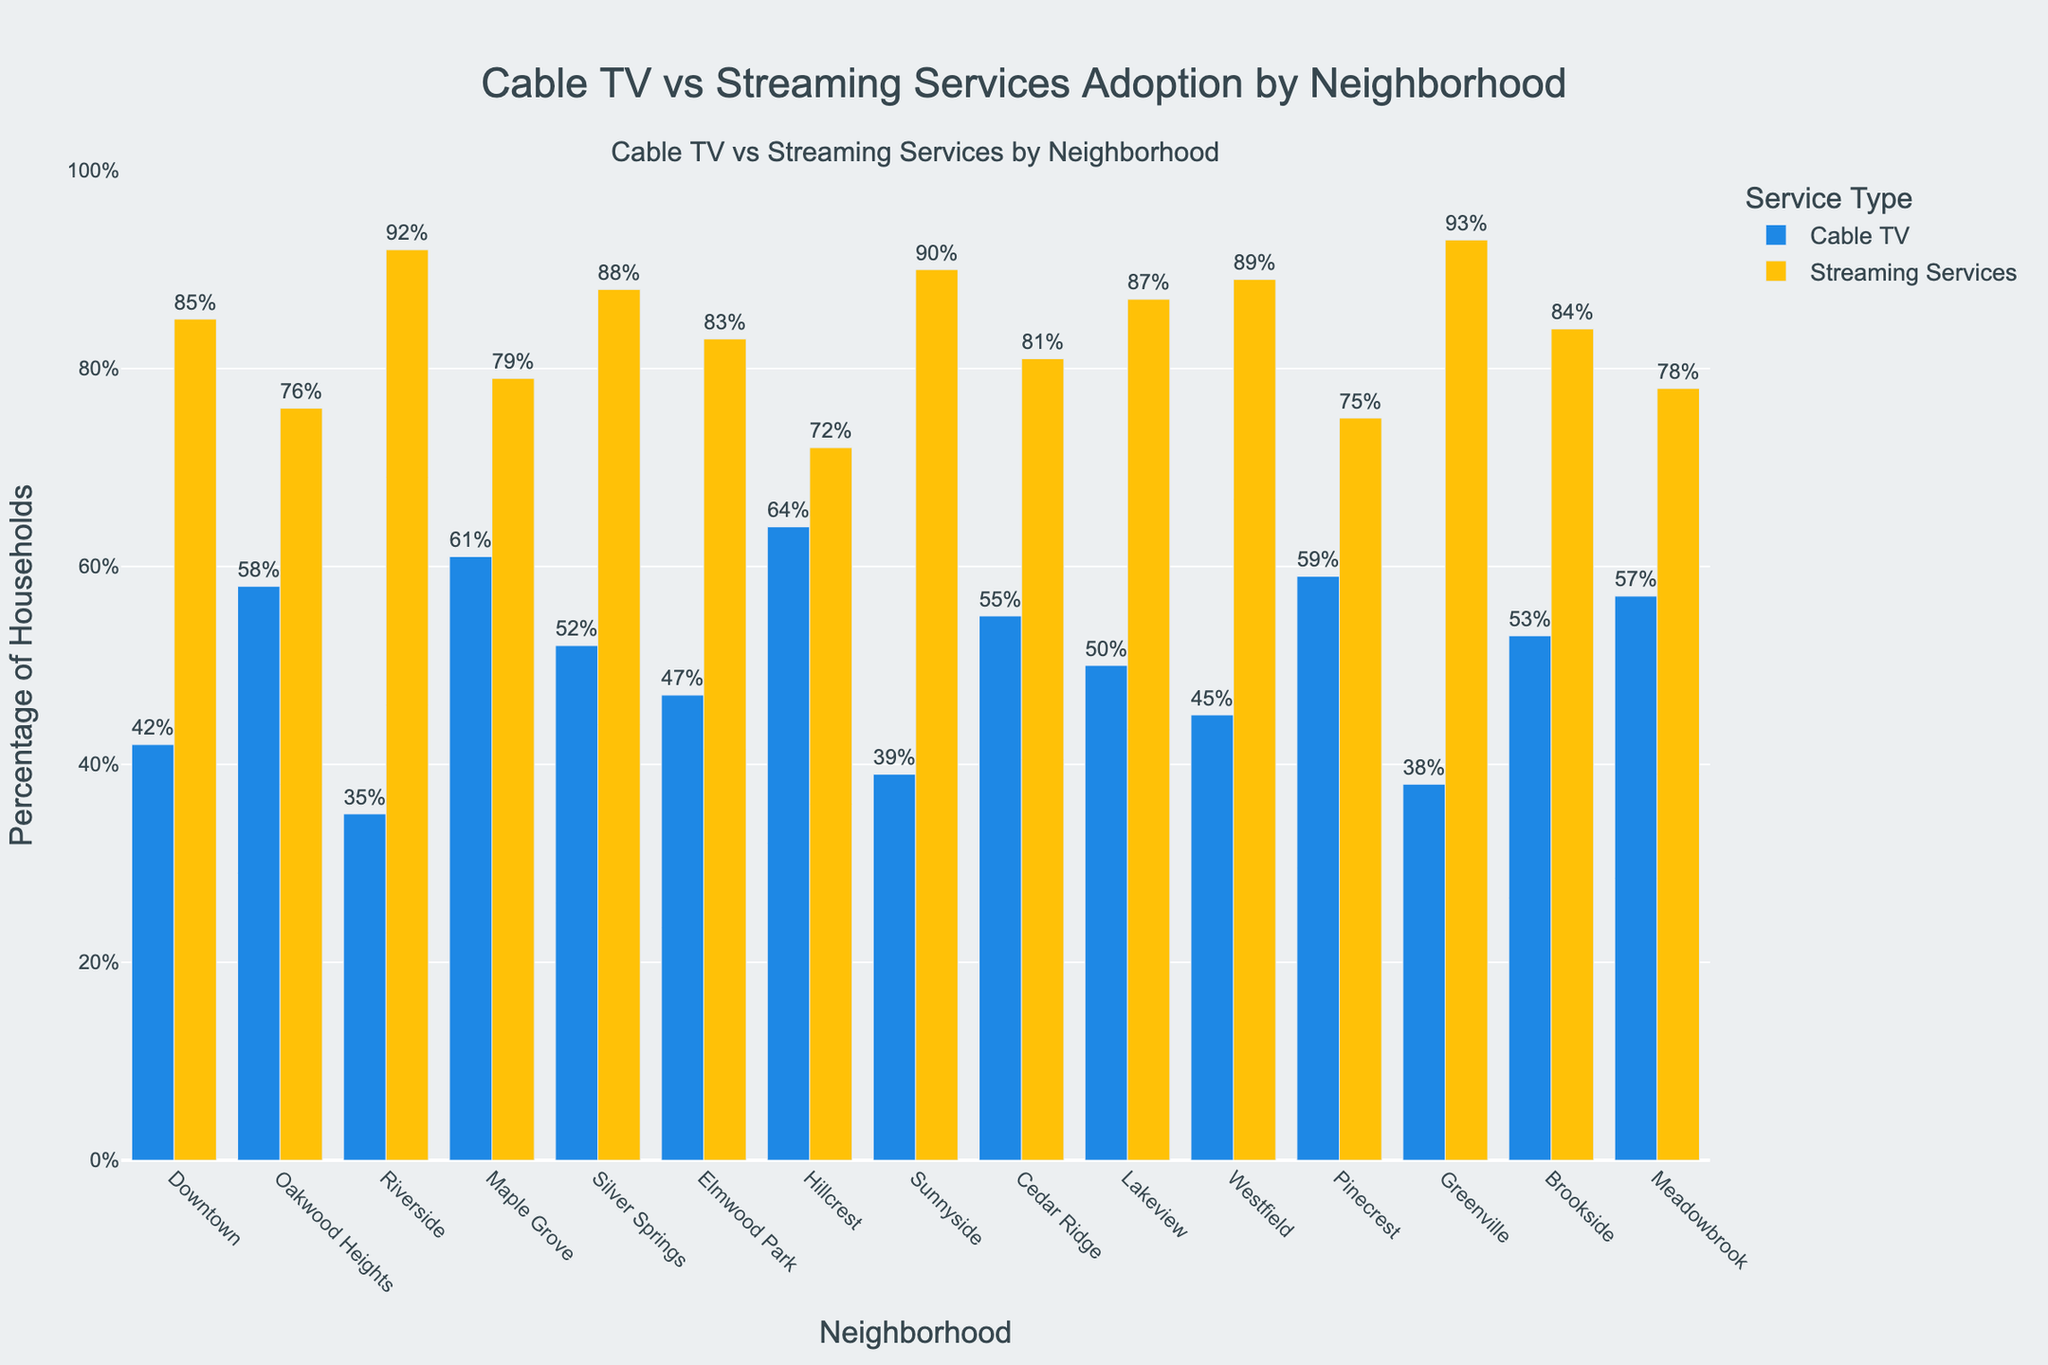Which neighborhood has the highest percentage of cable TV subscriptions? Scan the bar heights for Cable TV percentages and identify the highest bar. Hillcrest has the highest percentage at 64%.
Answer: Hillcrest Which neighborhood has the lowest percentage of streaming services subscriptions? Scan the bar heights for Streaming Services percentages and identify the shortest bar. Hillcrest has the lowest percentage at 72%.
Answer: Hillcrest What is the difference in percentage between cable TV and streaming services for Downtown? Identify the bar heights for Downtown in both categories. Streaming Services is 85% and Cable TV is 42%. Calculate the difference: 85% - 42% = 43%.
Answer: 43% Which neighborhood shows the smallest gap between cable TV and streaming services subscriptions? Calculate the absolute differences for each neighborhood and find the smallest. Oakwood Heights has the smallest gap with
Answer: Oakwood Heights How many neighborhoods have a cable TV subscription percentage higher than 50%? Count the number of neighborhoods where the Cable TV percentage bar is above the 50% line. There are six neighborhoods: Oakwood Heights, Maple Grove, Silver Springs, Hillcrest, Cedar Ridge, and Pinecrest.
Answer: 6 What is the average percentage of streaming services across all neighborhoods? Add all streaming services percentages and divide by the total number of neighborhoods. (85 + 76 + 92 + 79 + 88 + 83 + 72 + 90 + 81 + 87 + 89 + 75 + 93 + 84 + 78) / 15 = 82.1%.
Answer: 82.1% Which neighborhoods have higher percentages of streaming services than cable TV? Compare Cable TV and Streaming Services bars for each neighborhood. Riverside, Sunnyside, Greenville, Westfield, Silver Springs, Downtown, Elmwood Park, Cedar Ridge, and Brookside all have higher streaming services percentages.
Answer: 9 What is the median value of cable TV subscriptions across all neighborhoods? List the Cable TV percentages in ascending order and find the middle value. (35, 38, 39, 42, 45, 47, 50, 52, 53, 55, 57, 58, 59, 61, 64), so the median is 53%.
Answer: 53% In which neighborhood do the bars for cable TV and streaming services have the least height difference? Calculate the height differences for each neighborhood and find the smallest difference. Oakwood Heights has the least difference, 58% vs. 76%, difference = 18%.
Answer: Oakwood Heights Identify all neighborhoods where the percentage of cable TV subscriptions is below the average percentage for streaming services. Calculate the average streaming services percentage which is 82.1%. Identify neighborhoods with Cable TV percentages below 82.1%. Riverside, Sunnyside, Greenville, Westfield, Silver Springs, Downtown, Elmwood Park, and Brookside all meet this criterion.
Answer: 8 